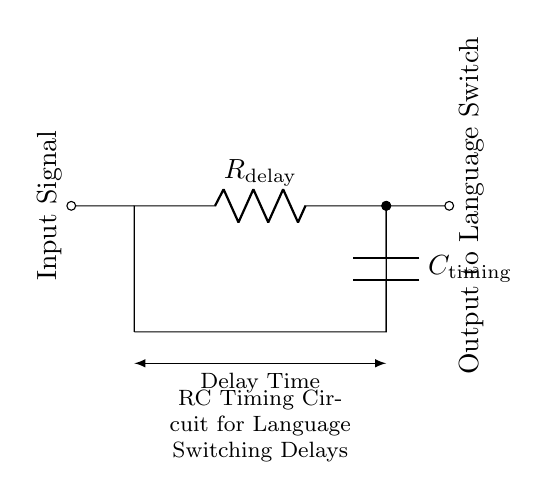What type of circuit is shown? The circuit is an RC timing circuit, which consists of a resistor and a capacitor. This type of circuit is used for timing applications such as controlling delays.
Answer: RC timing circuit What is the role of the resistor? The resistor, labeled as R delay, is responsible for controlling the charge and discharge time of the capacitor in the circuit, thereby influencing the timing delay characteristic.
Answer: Control timing delay What is the function of the capacitor? The capacitor, labeled as C timing, stores electrical energy and manages the timing delay based on its charge and discharge behavior when paired with the resistor.
Answer: Store energy How is the input signal represented? The input signal is represented on the left side of the diagram, indicated by a line connecting to the RC circuit, and is labeled as Input Signal.
Answer: Left side connection What happens to the output signal when the RC circuit charges? When the RC circuit charges, the output signal to the language switch changes state after a certain delay determined by the resistor and capacitor values, effectively controlling when the language switch is activated.
Answer: Delayed output change What aspect of language switching does this circuit control? This circuit controls the timing delay between language switching events in localization software, enabling a smoother user experience with timely language updates.
Answer: Language switching delay What is the delay time dependent on? The delay time is dependent on both the resistor and capacitor values, as the time constant (tau) is determined by the formula tau equals R multiplied by C, which dictates how fast the circuit responds.
Answer: Resistor and capacitor values 